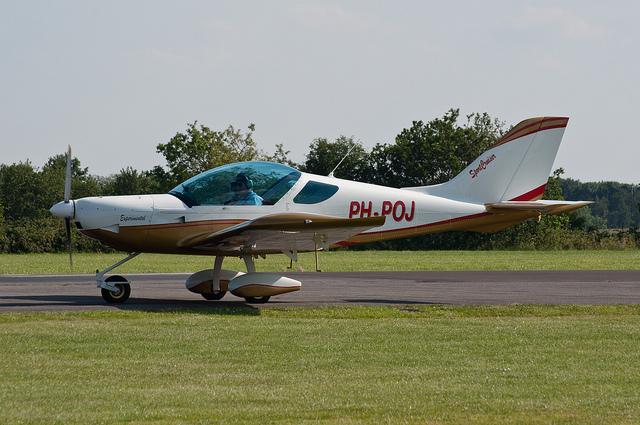What kind of plane is this?
Concise answer only. Airplane. Where is the plane?
Quick response, please. Runway. How many wheels are visible?
Concise answer only. 3. 